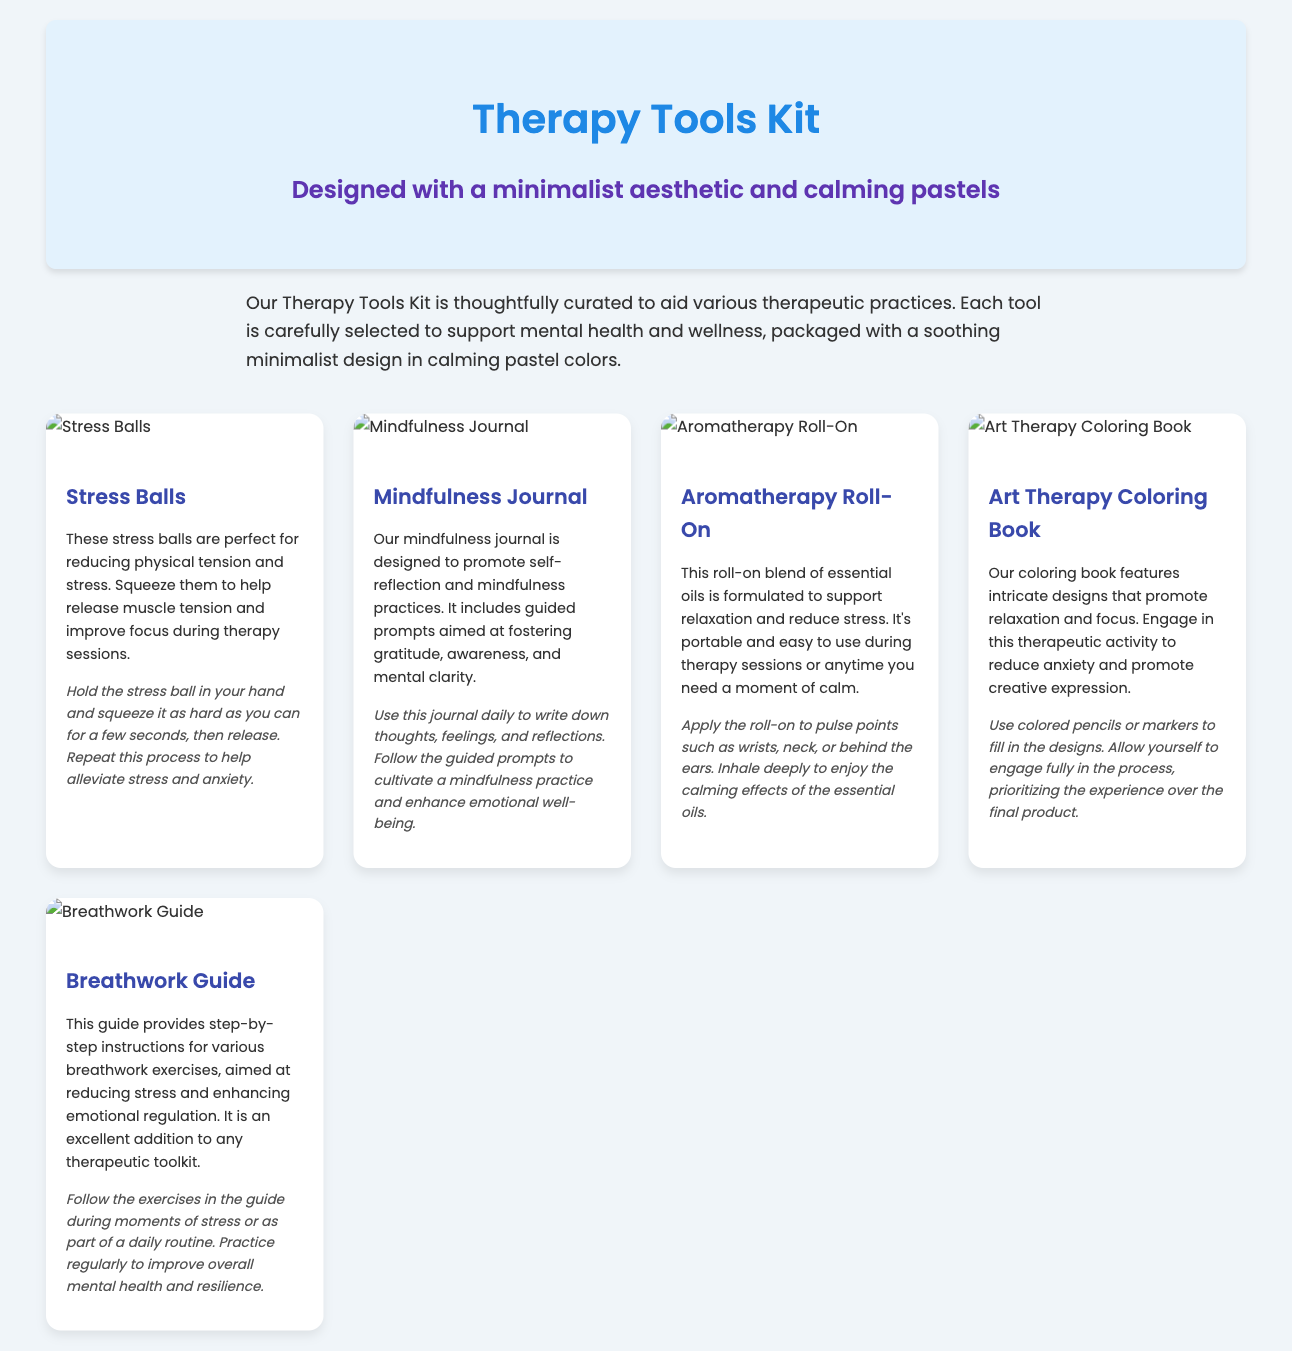What is the first tool listed in the kit? The first tool listed is the "Stress Balls."
Answer: Stress Balls What color palette is used for the packaging design? The design includes calming pastels.
Answer: Calming pastels How many different tools are included in the Therapy Tools Kit? There are five tools included in the kit.
Answer: Five What is the therapeutic application of the Mindfulness Journal? The journal is designed to promote self-reflection and mindfulness practices.
Answer: Promote self-reflection and mindfulness practices What is the primary benefit of using the Aromatherapy Roll-On? The roll-on supports relaxation and reduces stress.
Answer: Supports relaxation and reduces stress What activity does the Art Therapy Coloring Book promote? It promotes relaxation and focus.
Answer: Relaxation and focus In what manner should the Stress Balls be used? Hold and squeeze them to release muscle tension.
Answer: Hold and squeeze What is the purpose of the Breathwork Guide? It provides step-by-step instructions for breathwork exercises.
Answer: Step-by-step instructions for breathwork exercises 